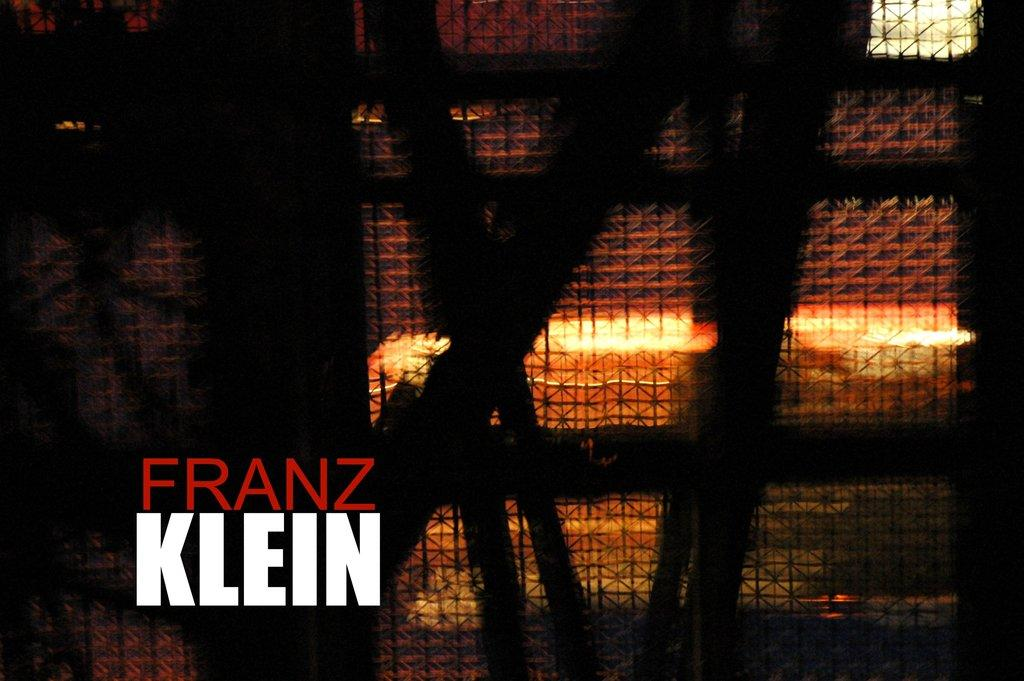What text is visible at the left side of the image? The text "franz klein" is written at the left side of the image. What type of structure can be seen in the image? There is a fence in the image. What additional feature is present in the image? There are lights in the image. How would you describe the appearance of the fence and lights in the image? The fence and lights are blurred in the image. How many bells are hanging from the fence in the image? There are no bells visible in the image; it only features a fence and lights. What type of star can be seen in the image? There is no star present in the image. 